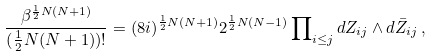Convert formula to latex. <formula><loc_0><loc_0><loc_500><loc_500>\frac { \beta ^ { \frac { 1 } { 2 } N ( N + 1 ) } } { ( \frac { 1 } { 2 } N ( N + 1 ) ) ! } = ( 8 i ) ^ { \frac { 1 } { 2 } N ( N + 1 ) } 2 ^ { \frac { 1 } { 2 } N ( N - 1 ) } \prod \nolimits _ { i \leq j } d Z _ { i j } \wedge d \bar { Z } _ { i j } \, ,</formula> 